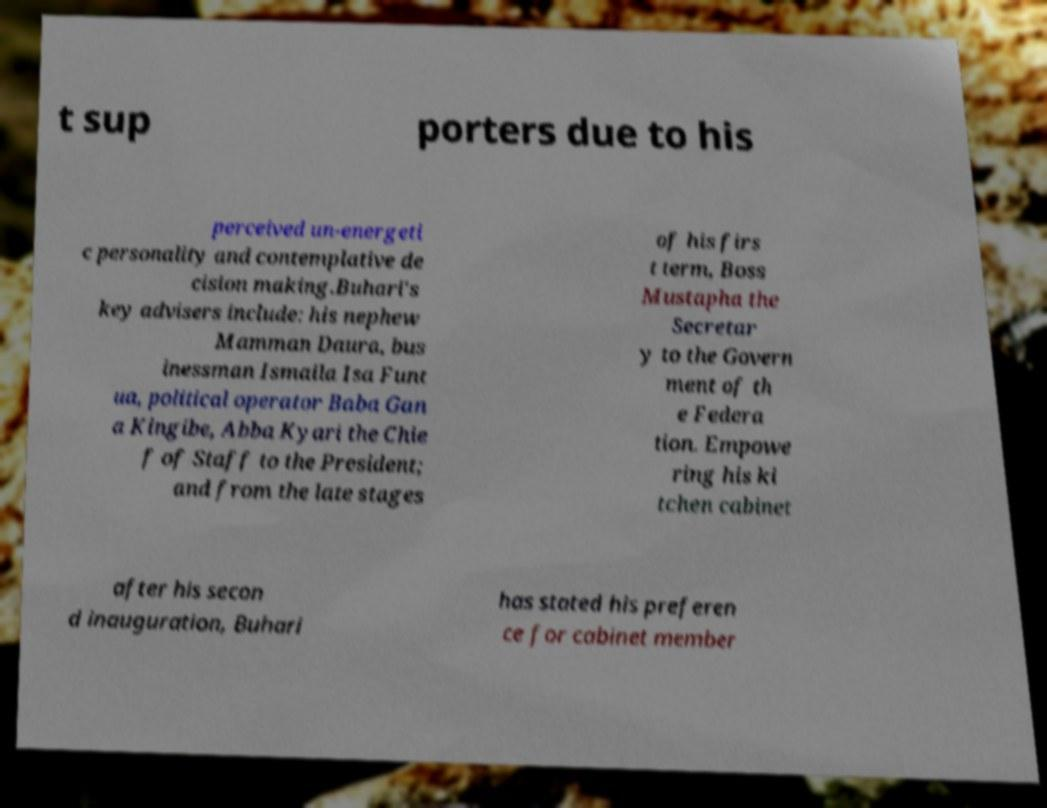Could you assist in decoding the text presented in this image and type it out clearly? t sup porters due to his perceived un-energeti c personality and contemplative de cision making.Buhari's key advisers include: his nephew Mamman Daura, bus inessman Ismaila Isa Funt ua, political operator Baba Gan a Kingibe, Abba Kyari the Chie f of Staff to the President; and from the late stages of his firs t term, Boss Mustapha the Secretar y to the Govern ment of th e Federa tion. Empowe ring his ki tchen cabinet after his secon d inauguration, Buhari has stated his preferen ce for cabinet member 